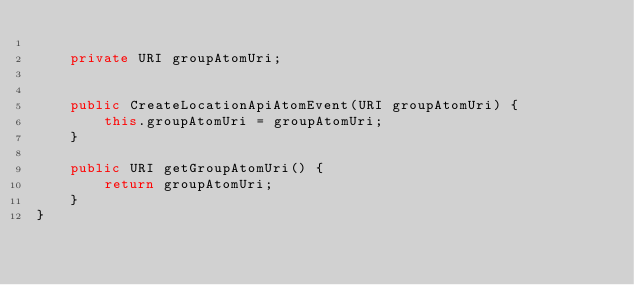<code> <loc_0><loc_0><loc_500><loc_500><_Java_>
    private URI groupAtomUri;


    public CreateLocationApiAtomEvent(URI groupAtomUri) {
        this.groupAtomUri = groupAtomUri;
    }

    public URI getGroupAtomUri() {
        return groupAtomUri;
    }
}
</code> 